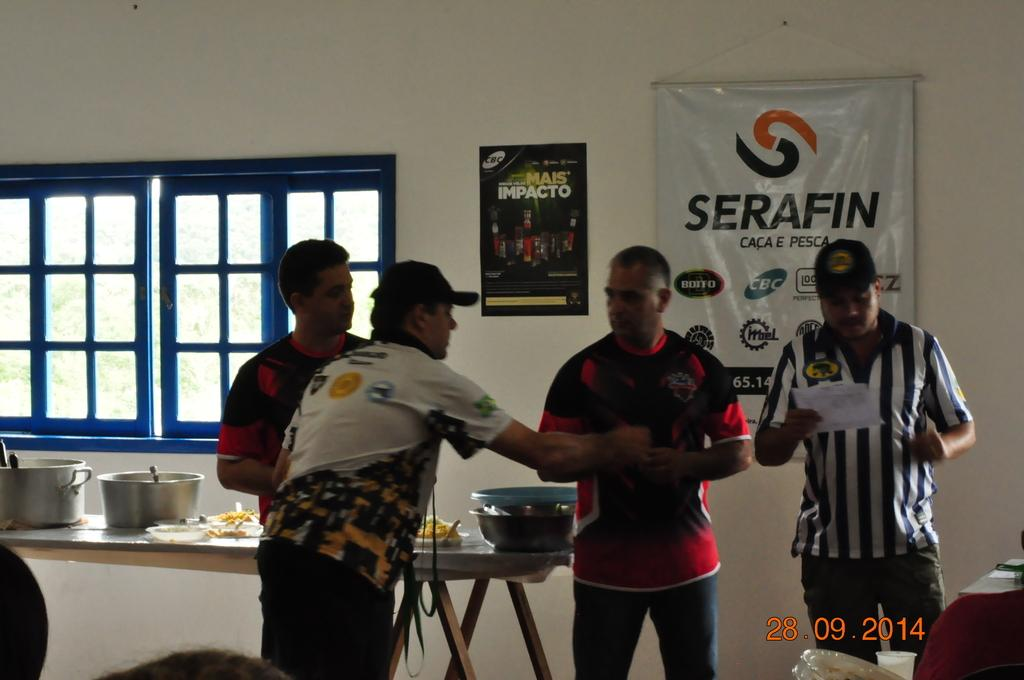<image>
Relay a brief, clear account of the picture shown. Men stand in front of a banner advertising Serafin. 